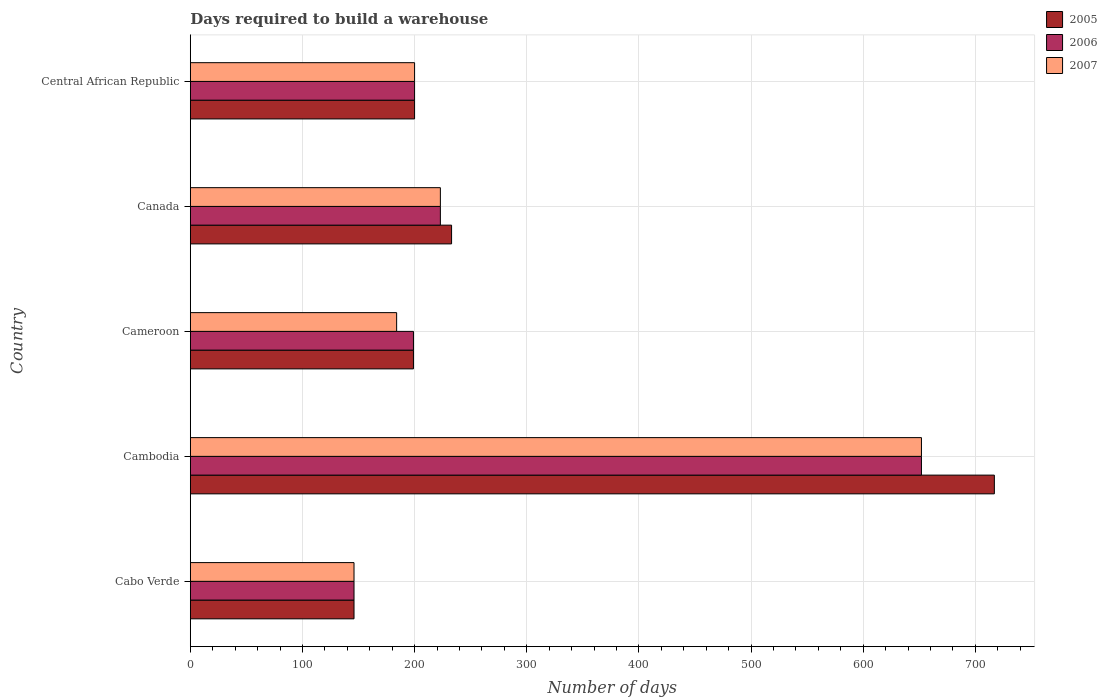Are the number of bars per tick equal to the number of legend labels?
Provide a short and direct response. Yes. What is the label of the 1st group of bars from the top?
Provide a succinct answer. Central African Republic. What is the days required to build a warehouse in in 2006 in Cabo Verde?
Your response must be concise. 146. Across all countries, what is the maximum days required to build a warehouse in in 2006?
Give a very brief answer. 652. Across all countries, what is the minimum days required to build a warehouse in in 2005?
Ensure brevity in your answer.  146. In which country was the days required to build a warehouse in in 2007 maximum?
Make the answer very short. Cambodia. In which country was the days required to build a warehouse in in 2005 minimum?
Keep it short and to the point. Cabo Verde. What is the total days required to build a warehouse in in 2007 in the graph?
Ensure brevity in your answer.  1405. What is the difference between the days required to build a warehouse in in 2005 in Cabo Verde and that in Cambodia?
Give a very brief answer. -571. What is the difference between the days required to build a warehouse in in 2007 in Cameroon and the days required to build a warehouse in in 2005 in Canada?
Provide a succinct answer. -49. What is the average days required to build a warehouse in in 2007 per country?
Provide a short and direct response. 281. What is the ratio of the days required to build a warehouse in in 2007 in Cabo Verde to that in Cambodia?
Keep it short and to the point. 0.22. Is the days required to build a warehouse in in 2005 in Cameroon less than that in Central African Republic?
Provide a succinct answer. Yes. What is the difference between the highest and the second highest days required to build a warehouse in in 2006?
Keep it short and to the point. 429. What is the difference between the highest and the lowest days required to build a warehouse in in 2006?
Make the answer very short. 506. In how many countries, is the days required to build a warehouse in in 2005 greater than the average days required to build a warehouse in in 2005 taken over all countries?
Keep it short and to the point. 1. What does the 3rd bar from the bottom in Cambodia represents?
Your response must be concise. 2007. Are the values on the major ticks of X-axis written in scientific E-notation?
Keep it short and to the point. No. Where does the legend appear in the graph?
Ensure brevity in your answer.  Top right. How many legend labels are there?
Your answer should be very brief. 3. How are the legend labels stacked?
Give a very brief answer. Vertical. What is the title of the graph?
Make the answer very short. Days required to build a warehouse. Does "2001" appear as one of the legend labels in the graph?
Offer a terse response. No. What is the label or title of the X-axis?
Ensure brevity in your answer.  Number of days. What is the Number of days of 2005 in Cabo Verde?
Offer a very short reply. 146. What is the Number of days in 2006 in Cabo Verde?
Your answer should be compact. 146. What is the Number of days in 2007 in Cabo Verde?
Offer a terse response. 146. What is the Number of days in 2005 in Cambodia?
Your response must be concise. 717. What is the Number of days in 2006 in Cambodia?
Offer a terse response. 652. What is the Number of days in 2007 in Cambodia?
Offer a very short reply. 652. What is the Number of days of 2005 in Cameroon?
Ensure brevity in your answer.  199. What is the Number of days of 2006 in Cameroon?
Give a very brief answer. 199. What is the Number of days in 2007 in Cameroon?
Provide a short and direct response. 184. What is the Number of days of 2005 in Canada?
Offer a terse response. 233. What is the Number of days of 2006 in Canada?
Your answer should be very brief. 223. What is the Number of days of 2007 in Canada?
Ensure brevity in your answer.  223. What is the Number of days of 2005 in Central African Republic?
Provide a succinct answer. 200. What is the Number of days in 2006 in Central African Republic?
Ensure brevity in your answer.  200. What is the Number of days in 2007 in Central African Republic?
Your answer should be compact. 200. Across all countries, what is the maximum Number of days of 2005?
Offer a very short reply. 717. Across all countries, what is the maximum Number of days in 2006?
Provide a succinct answer. 652. Across all countries, what is the maximum Number of days of 2007?
Provide a succinct answer. 652. Across all countries, what is the minimum Number of days of 2005?
Offer a very short reply. 146. Across all countries, what is the minimum Number of days in 2006?
Ensure brevity in your answer.  146. Across all countries, what is the minimum Number of days in 2007?
Your answer should be compact. 146. What is the total Number of days of 2005 in the graph?
Offer a very short reply. 1495. What is the total Number of days in 2006 in the graph?
Ensure brevity in your answer.  1420. What is the total Number of days in 2007 in the graph?
Offer a terse response. 1405. What is the difference between the Number of days in 2005 in Cabo Verde and that in Cambodia?
Your answer should be compact. -571. What is the difference between the Number of days of 2006 in Cabo Verde and that in Cambodia?
Your answer should be compact. -506. What is the difference between the Number of days in 2007 in Cabo Verde and that in Cambodia?
Provide a short and direct response. -506. What is the difference between the Number of days in 2005 in Cabo Verde and that in Cameroon?
Provide a succinct answer. -53. What is the difference between the Number of days of 2006 in Cabo Verde and that in Cameroon?
Give a very brief answer. -53. What is the difference between the Number of days in 2007 in Cabo Verde and that in Cameroon?
Ensure brevity in your answer.  -38. What is the difference between the Number of days of 2005 in Cabo Verde and that in Canada?
Provide a short and direct response. -87. What is the difference between the Number of days in 2006 in Cabo Verde and that in Canada?
Provide a succinct answer. -77. What is the difference between the Number of days of 2007 in Cabo Verde and that in Canada?
Provide a succinct answer. -77. What is the difference between the Number of days of 2005 in Cabo Verde and that in Central African Republic?
Offer a very short reply. -54. What is the difference between the Number of days in 2006 in Cabo Verde and that in Central African Republic?
Make the answer very short. -54. What is the difference between the Number of days in 2007 in Cabo Verde and that in Central African Republic?
Your answer should be compact. -54. What is the difference between the Number of days in 2005 in Cambodia and that in Cameroon?
Ensure brevity in your answer.  518. What is the difference between the Number of days in 2006 in Cambodia and that in Cameroon?
Offer a very short reply. 453. What is the difference between the Number of days of 2007 in Cambodia and that in Cameroon?
Provide a short and direct response. 468. What is the difference between the Number of days of 2005 in Cambodia and that in Canada?
Provide a short and direct response. 484. What is the difference between the Number of days of 2006 in Cambodia and that in Canada?
Your answer should be compact. 429. What is the difference between the Number of days of 2007 in Cambodia and that in Canada?
Ensure brevity in your answer.  429. What is the difference between the Number of days in 2005 in Cambodia and that in Central African Republic?
Give a very brief answer. 517. What is the difference between the Number of days of 2006 in Cambodia and that in Central African Republic?
Keep it short and to the point. 452. What is the difference between the Number of days in 2007 in Cambodia and that in Central African Republic?
Provide a succinct answer. 452. What is the difference between the Number of days in 2005 in Cameroon and that in Canada?
Provide a short and direct response. -34. What is the difference between the Number of days of 2007 in Cameroon and that in Canada?
Your answer should be very brief. -39. What is the difference between the Number of days of 2006 in Cameroon and that in Central African Republic?
Give a very brief answer. -1. What is the difference between the Number of days in 2007 in Canada and that in Central African Republic?
Provide a short and direct response. 23. What is the difference between the Number of days in 2005 in Cabo Verde and the Number of days in 2006 in Cambodia?
Offer a terse response. -506. What is the difference between the Number of days of 2005 in Cabo Verde and the Number of days of 2007 in Cambodia?
Your answer should be compact. -506. What is the difference between the Number of days in 2006 in Cabo Verde and the Number of days in 2007 in Cambodia?
Offer a terse response. -506. What is the difference between the Number of days in 2005 in Cabo Verde and the Number of days in 2006 in Cameroon?
Your answer should be very brief. -53. What is the difference between the Number of days of 2005 in Cabo Verde and the Number of days of 2007 in Cameroon?
Provide a short and direct response. -38. What is the difference between the Number of days in 2006 in Cabo Verde and the Number of days in 2007 in Cameroon?
Your response must be concise. -38. What is the difference between the Number of days in 2005 in Cabo Verde and the Number of days in 2006 in Canada?
Provide a short and direct response. -77. What is the difference between the Number of days in 2005 in Cabo Verde and the Number of days in 2007 in Canada?
Your response must be concise. -77. What is the difference between the Number of days in 2006 in Cabo Verde and the Number of days in 2007 in Canada?
Ensure brevity in your answer.  -77. What is the difference between the Number of days in 2005 in Cabo Verde and the Number of days in 2006 in Central African Republic?
Your response must be concise. -54. What is the difference between the Number of days of 2005 in Cabo Verde and the Number of days of 2007 in Central African Republic?
Provide a short and direct response. -54. What is the difference between the Number of days of 2006 in Cabo Verde and the Number of days of 2007 in Central African Republic?
Keep it short and to the point. -54. What is the difference between the Number of days in 2005 in Cambodia and the Number of days in 2006 in Cameroon?
Your answer should be compact. 518. What is the difference between the Number of days in 2005 in Cambodia and the Number of days in 2007 in Cameroon?
Provide a succinct answer. 533. What is the difference between the Number of days in 2006 in Cambodia and the Number of days in 2007 in Cameroon?
Make the answer very short. 468. What is the difference between the Number of days in 2005 in Cambodia and the Number of days in 2006 in Canada?
Keep it short and to the point. 494. What is the difference between the Number of days in 2005 in Cambodia and the Number of days in 2007 in Canada?
Ensure brevity in your answer.  494. What is the difference between the Number of days in 2006 in Cambodia and the Number of days in 2007 in Canada?
Keep it short and to the point. 429. What is the difference between the Number of days in 2005 in Cambodia and the Number of days in 2006 in Central African Republic?
Ensure brevity in your answer.  517. What is the difference between the Number of days in 2005 in Cambodia and the Number of days in 2007 in Central African Republic?
Provide a succinct answer. 517. What is the difference between the Number of days of 2006 in Cambodia and the Number of days of 2007 in Central African Republic?
Ensure brevity in your answer.  452. What is the difference between the Number of days of 2005 in Cameroon and the Number of days of 2007 in Canada?
Your answer should be very brief. -24. What is the difference between the Number of days of 2005 in Canada and the Number of days of 2006 in Central African Republic?
Provide a succinct answer. 33. What is the difference between the Number of days in 2005 in Canada and the Number of days in 2007 in Central African Republic?
Your answer should be compact. 33. What is the difference between the Number of days in 2006 in Canada and the Number of days in 2007 in Central African Republic?
Provide a short and direct response. 23. What is the average Number of days of 2005 per country?
Your answer should be compact. 299. What is the average Number of days of 2006 per country?
Offer a terse response. 284. What is the average Number of days of 2007 per country?
Your response must be concise. 281. What is the difference between the Number of days of 2005 and Number of days of 2006 in Cabo Verde?
Offer a terse response. 0. What is the difference between the Number of days of 2005 and Number of days of 2007 in Cabo Verde?
Offer a terse response. 0. What is the difference between the Number of days in 2005 and Number of days in 2006 in Cambodia?
Provide a short and direct response. 65. What is the difference between the Number of days in 2006 and Number of days in 2007 in Cambodia?
Offer a very short reply. 0. What is the difference between the Number of days of 2005 and Number of days of 2006 in Cameroon?
Offer a very short reply. 0. What is the difference between the Number of days in 2005 and Number of days in 2006 in Canada?
Provide a short and direct response. 10. What is the difference between the Number of days of 2006 and Number of days of 2007 in Central African Republic?
Provide a short and direct response. 0. What is the ratio of the Number of days in 2005 in Cabo Verde to that in Cambodia?
Keep it short and to the point. 0.2. What is the ratio of the Number of days in 2006 in Cabo Verde to that in Cambodia?
Your response must be concise. 0.22. What is the ratio of the Number of days in 2007 in Cabo Verde to that in Cambodia?
Your answer should be very brief. 0.22. What is the ratio of the Number of days in 2005 in Cabo Verde to that in Cameroon?
Ensure brevity in your answer.  0.73. What is the ratio of the Number of days in 2006 in Cabo Verde to that in Cameroon?
Your response must be concise. 0.73. What is the ratio of the Number of days in 2007 in Cabo Verde to that in Cameroon?
Your answer should be compact. 0.79. What is the ratio of the Number of days of 2005 in Cabo Verde to that in Canada?
Provide a succinct answer. 0.63. What is the ratio of the Number of days in 2006 in Cabo Verde to that in Canada?
Offer a terse response. 0.65. What is the ratio of the Number of days in 2007 in Cabo Verde to that in Canada?
Offer a terse response. 0.65. What is the ratio of the Number of days of 2005 in Cabo Verde to that in Central African Republic?
Your answer should be very brief. 0.73. What is the ratio of the Number of days in 2006 in Cabo Verde to that in Central African Republic?
Keep it short and to the point. 0.73. What is the ratio of the Number of days of 2007 in Cabo Verde to that in Central African Republic?
Make the answer very short. 0.73. What is the ratio of the Number of days of 2005 in Cambodia to that in Cameroon?
Offer a very short reply. 3.6. What is the ratio of the Number of days in 2006 in Cambodia to that in Cameroon?
Keep it short and to the point. 3.28. What is the ratio of the Number of days in 2007 in Cambodia to that in Cameroon?
Offer a terse response. 3.54. What is the ratio of the Number of days of 2005 in Cambodia to that in Canada?
Keep it short and to the point. 3.08. What is the ratio of the Number of days in 2006 in Cambodia to that in Canada?
Provide a short and direct response. 2.92. What is the ratio of the Number of days of 2007 in Cambodia to that in Canada?
Your answer should be compact. 2.92. What is the ratio of the Number of days in 2005 in Cambodia to that in Central African Republic?
Your answer should be very brief. 3.58. What is the ratio of the Number of days of 2006 in Cambodia to that in Central African Republic?
Your answer should be very brief. 3.26. What is the ratio of the Number of days of 2007 in Cambodia to that in Central African Republic?
Ensure brevity in your answer.  3.26. What is the ratio of the Number of days in 2005 in Cameroon to that in Canada?
Keep it short and to the point. 0.85. What is the ratio of the Number of days in 2006 in Cameroon to that in Canada?
Ensure brevity in your answer.  0.89. What is the ratio of the Number of days in 2007 in Cameroon to that in Canada?
Make the answer very short. 0.83. What is the ratio of the Number of days of 2005 in Canada to that in Central African Republic?
Make the answer very short. 1.17. What is the ratio of the Number of days in 2006 in Canada to that in Central African Republic?
Provide a short and direct response. 1.11. What is the ratio of the Number of days in 2007 in Canada to that in Central African Republic?
Offer a terse response. 1.11. What is the difference between the highest and the second highest Number of days of 2005?
Your response must be concise. 484. What is the difference between the highest and the second highest Number of days in 2006?
Give a very brief answer. 429. What is the difference between the highest and the second highest Number of days of 2007?
Provide a short and direct response. 429. What is the difference between the highest and the lowest Number of days in 2005?
Make the answer very short. 571. What is the difference between the highest and the lowest Number of days in 2006?
Your response must be concise. 506. What is the difference between the highest and the lowest Number of days in 2007?
Your response must be concise. 506. 